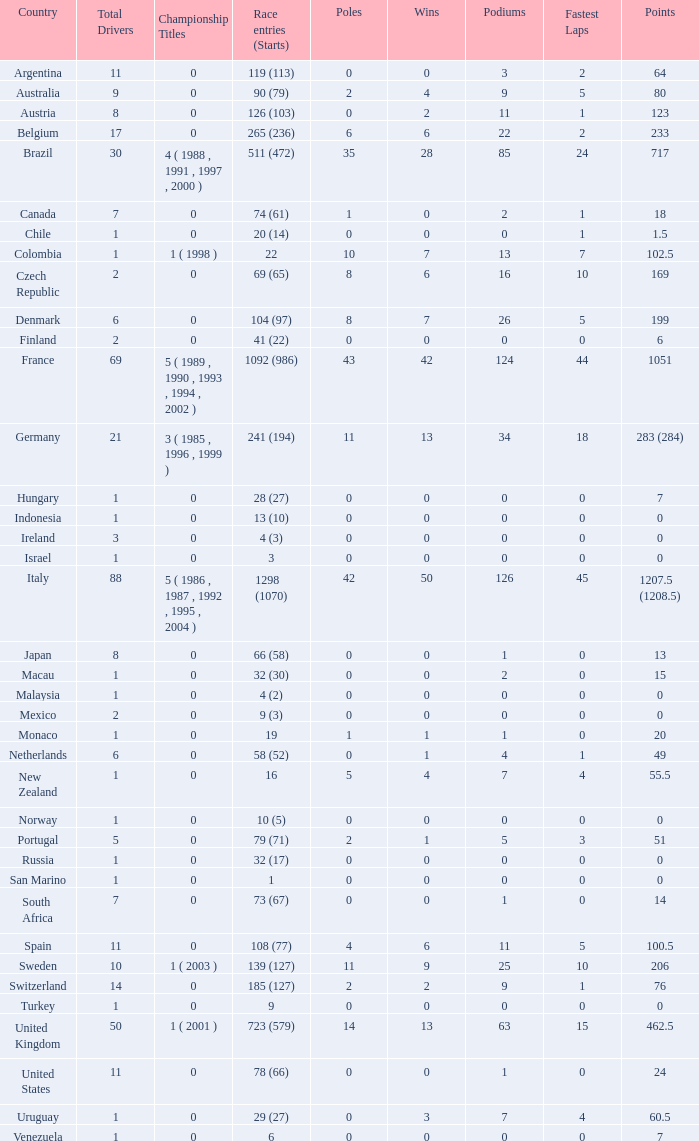How many fastest laps for the nation with 32 (30) entries and starts and fewer than 2 podiums? None. 